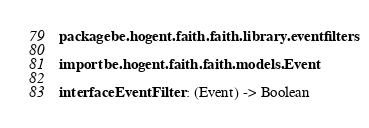Convert code to text. <code><loc_0><loc_0><loc_500><loc_500><_Kotlin_>package be.hogent.faith.faith.library.eventfilters

import be.hogent.faith.faith.models.Event

interface EventFilter : (Event) -> Boolean
</code> 